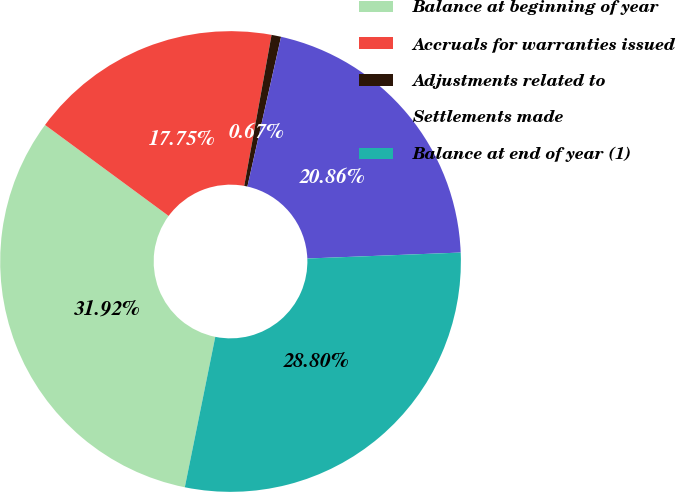Convert chart to OTSL. <chart><loc_0><loc_0><loc_500><loc_500><pie_chart><fcel>Balance at beginning of year<fcel>Accruals for warranties issued<fcel>Adjustments related to<fcel>Settlements made<fcel>Balance at end of year (1)<nl><fcel>31.92%<fcel>17.75%<fcel>0.67%<fcel>20.86%<fcel>28.8%<nl></chart> 